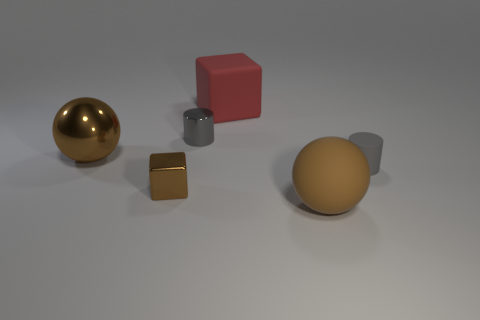Add 3 large objects. How many objects exist? 9 Subtract all cubes. How many objects are left? 4 Add 4 big cubes. How many big cubes are left? 5 Add 4 small metallic blocks. How many small metallic blocks exist? 5 Subtract 1 red cubes. How many objects are left? 5 Subtract all large blue rubber cylinders. Subtract all big brown shiny objects. How many objects are left? 5 